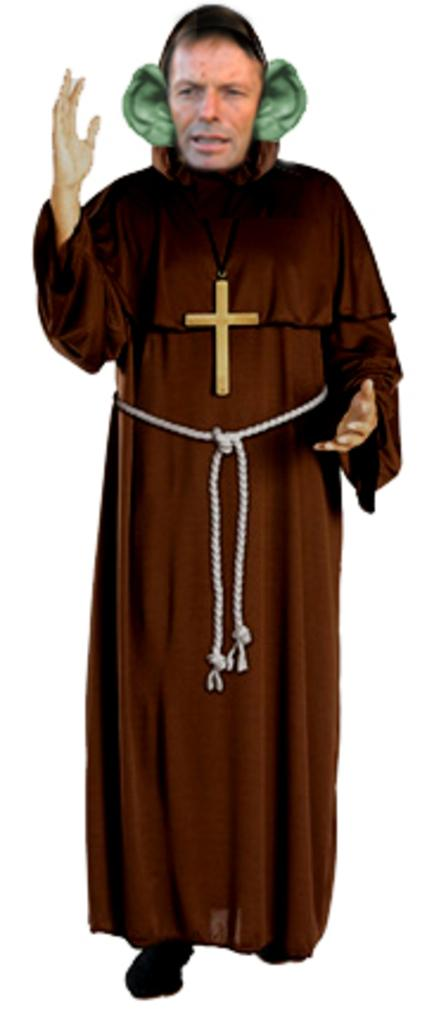What is the main subject of the image? There is a man in the image. What is the man wearing in the image? The man is wearing a cross. What color is the background of the image? The background of the image is white. Are there any musicians playing in a band in the image? There is no indication of a band or musicians playing in the image. Is the man in the image a minister? There is no information in the image to suggest that the man is a minister. 